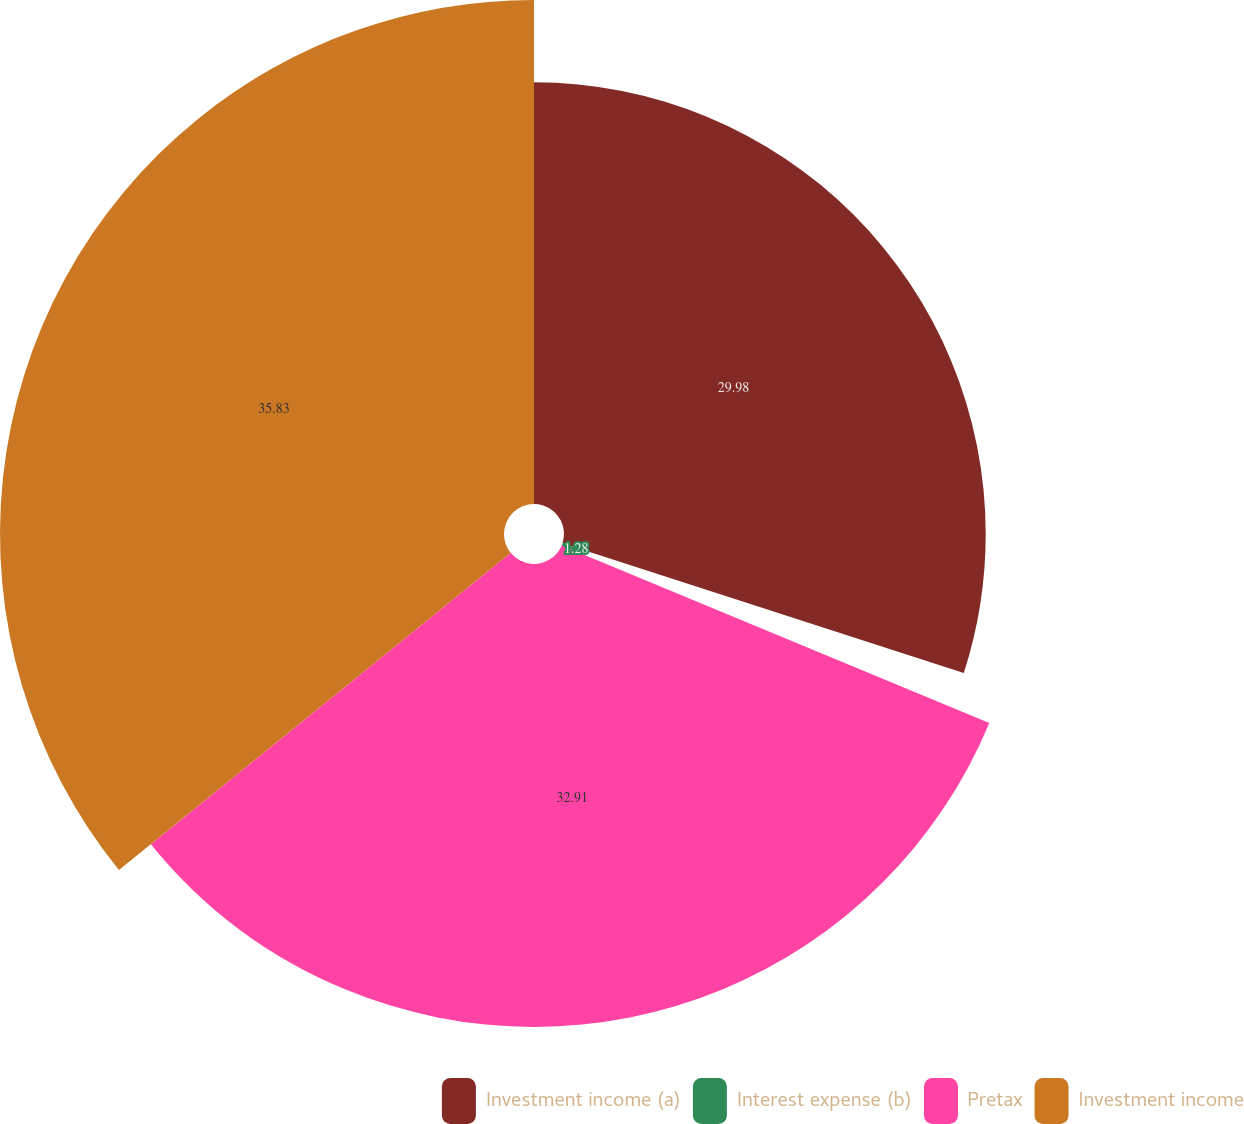Convert chart to OTSL. <chart><loc_0><loc_0><loc_500><loc_500><pie_chart><fcel>Investment income (a)<fcel>Interest expense (b)<fcel>Pretax<fcel>Investment income<nl><fcel>29.98%<fcel>1.28%<fcel>32.91%<fcel>35.83%<nl></chart> 